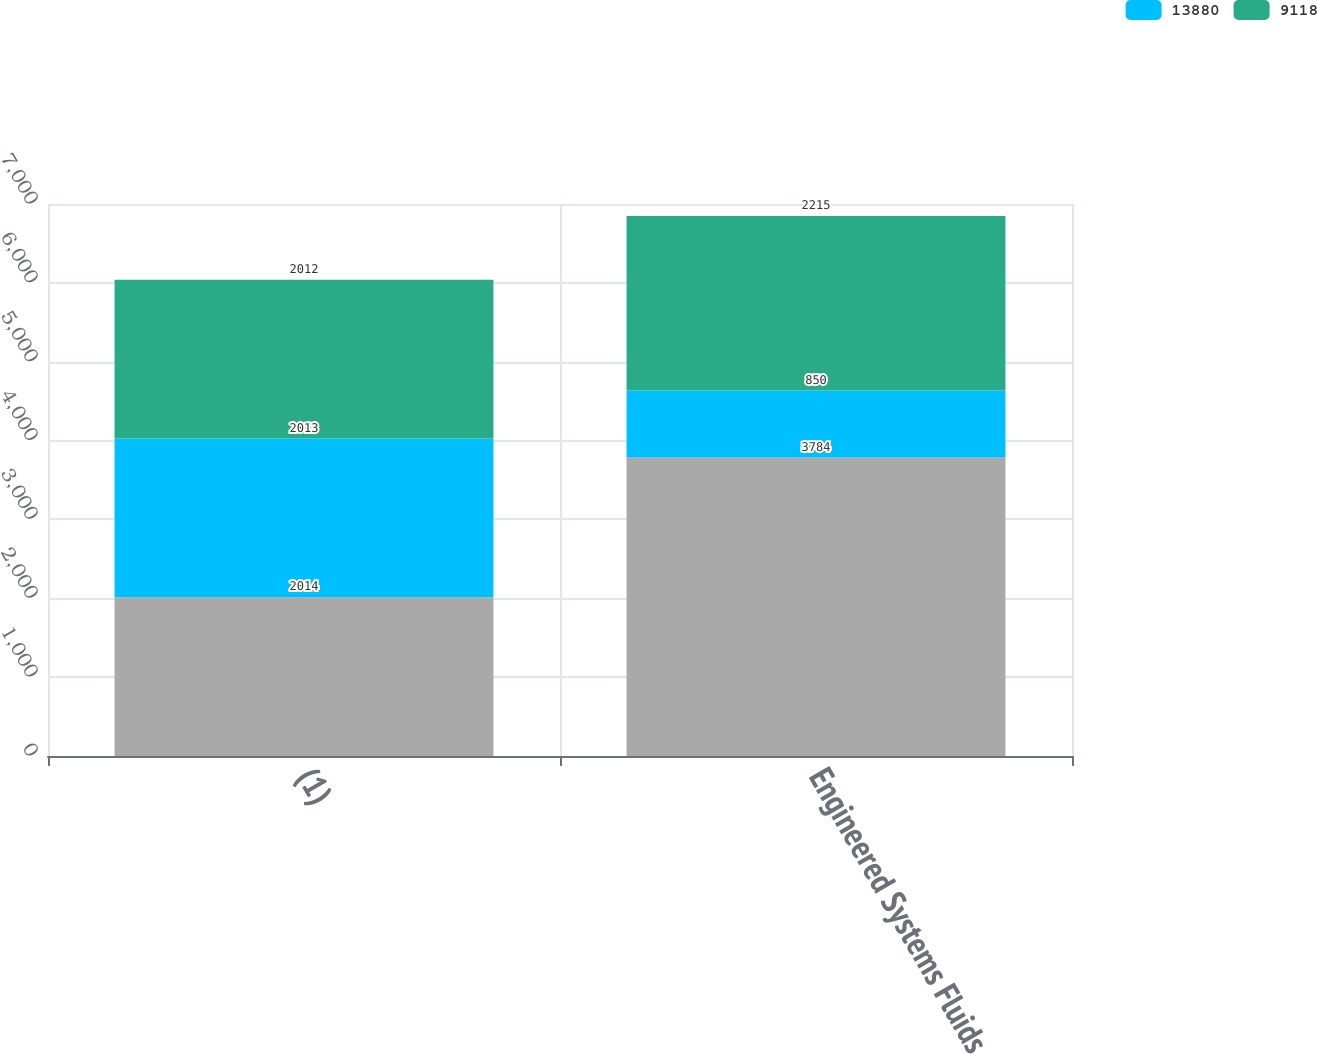<chart> <loc_0><loc_0><loc_500><loc_500><stacked_bar_chart><ecel><fcel>(1)<fcel>Engineered Systems Fluids<nl><fcel>nan<fcel>2014<fcel>3784<nl><fcel>13880<fcel>2013<fcel>850<nl><fcel>9118<fcel>2012<fcel>2215<nl></chart> 